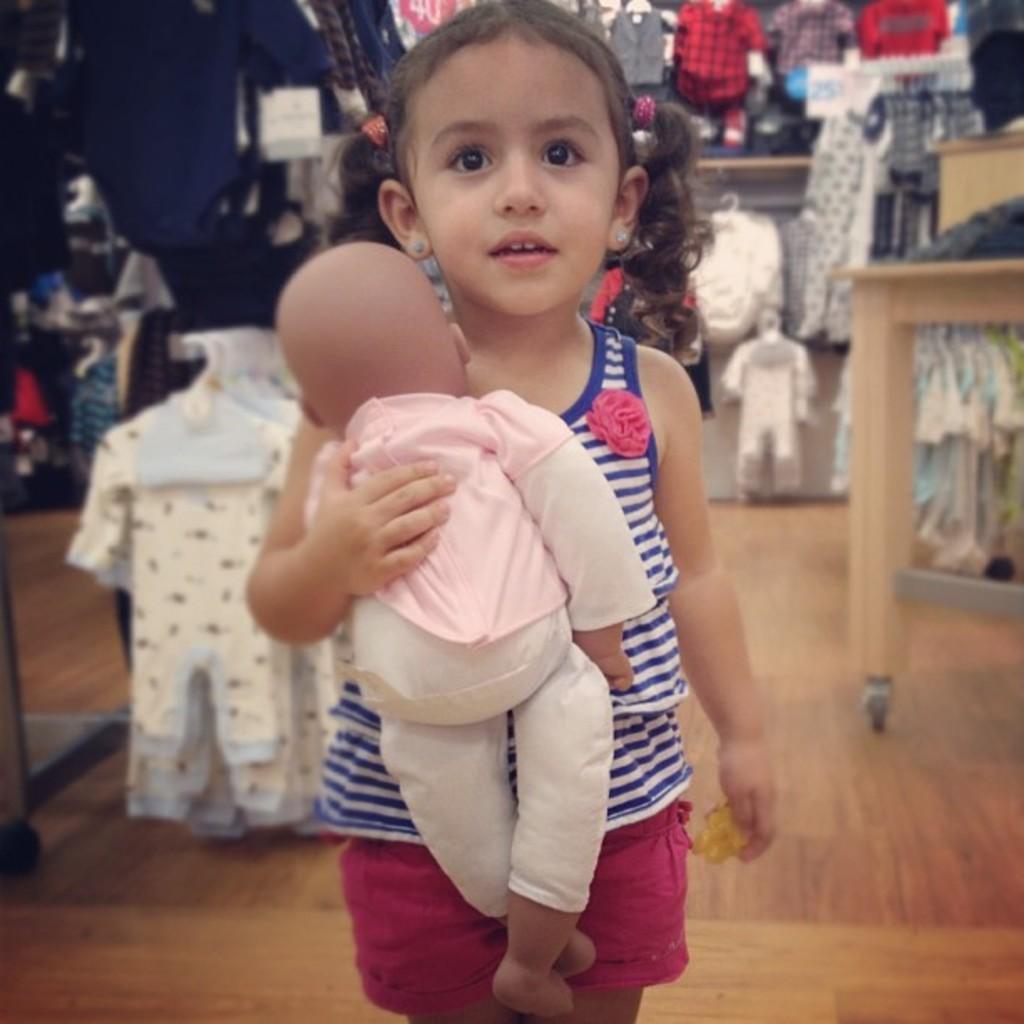How would you summarize this image in a sentence or two? This picture seems to be clicked inside the hall. In the foreground we can see a girl wearing t-shirt, holding a toy and standing. In the background we can see the clothes and we can see the tables, hangers and many other objects. 